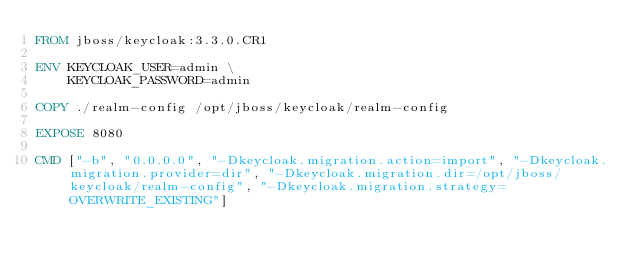<code> <loc_0><loc_0><loc_500><loc_500><_Dockerfile_>FROM jboss/keycloak:3.3.0.CR1

ENV KEYCLOAK_USER=admin \
    KEYCLOAK_PASSWORD=admin

COPY ./realm-config /opt/jboss/keycloak/realm-config

EXPOSE 8080

CMD ["-b", "0.0.0.0", "-Dkeycloak.migration.action=import", "-Dkeycloak.migration.provider=dir", "-Dkeycloak.migration.dir=/opt/jboss/keycloak/realm-config", "-Dkeycloak.migration.strategy=OVERWRITE_EXISTING"]</code> 